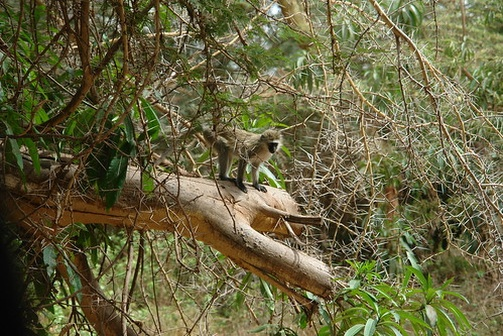What might be some challenges the monkey faces living in this environment? Living in the forest, the monkey faces a variety of challenges. Predators such as large birds of prey, snakes, and wildcats pose constant threats. To stay safe, the monkey must remain vigilant and quick, always ready to flee or hide. Another challenge is finding sufficient food, especially during dry seasons when resources are scarce. The forest can also be a competitive place, with other monkeys and animals vying for the sharegpt4v/same food and shelter. Additionally, weather conditions, such as heavy rains, storms, or extreme heat, can create hazardous or uncomfortable living conditions. Despite these challenges, the monkey adapts and learns to navigate its complex environment through experience and instinct. 